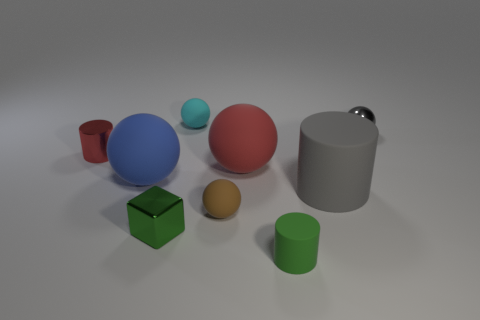Subtract all cyan balls. How many balls are left? 4 Subtract all small shiny spheres. How many spheres are left? 4 Subtract all purple cylinders. Subtract all brown balls. How many cylinders are left? 3 Add 1 blue matte spheres. How many objects exist? 10 Subtract all cylinders. How many objects are left? 6 Subtract all tiny red cylinders. Subtract all red objects. How many objects are left? 6 Add 8 large blue objects. How many large blue objects are left? 9 Add 3 cyan things. How many cyan things exist? 4 Subtract 1 gray cylinders. How many objects are left? 8 